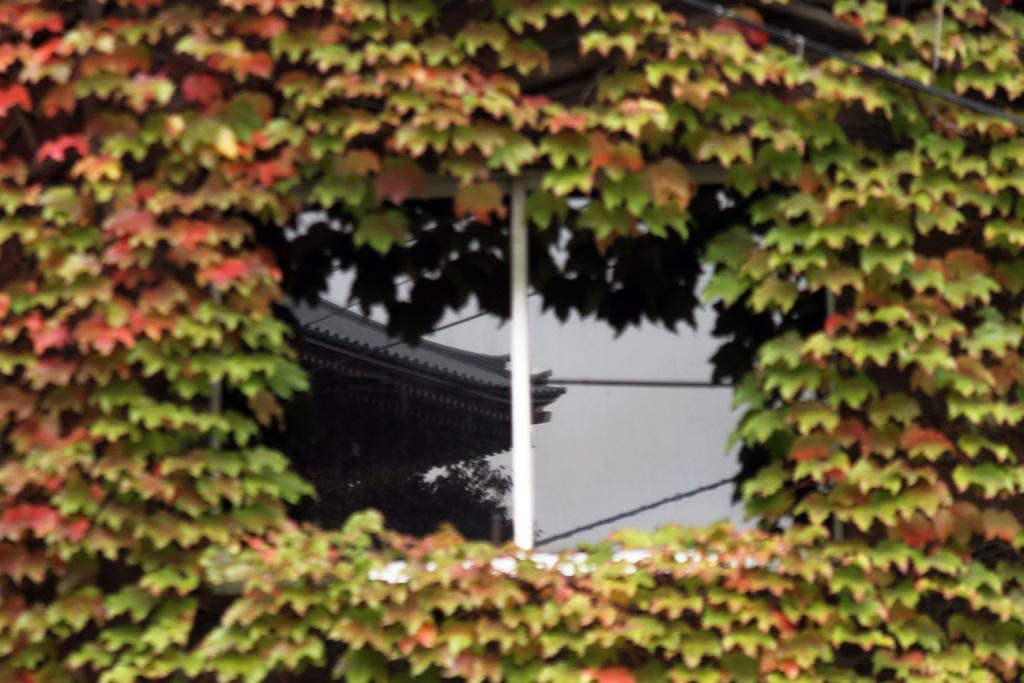Describe this image in one or two sentences. In this image in the foreground there are some plants, and in the center there is a window and through the window we could see a reflection of trees and wires. 